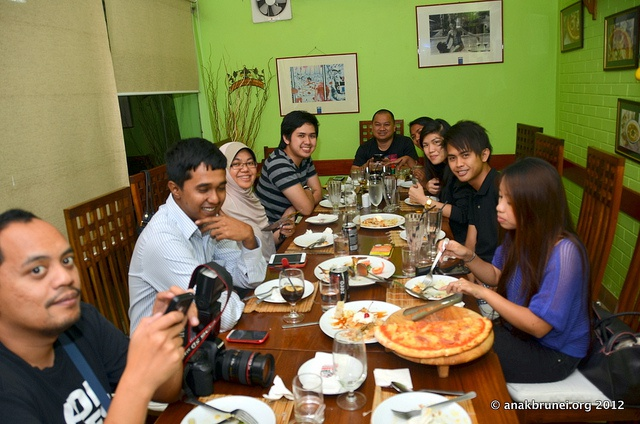Describe the objects in this image and their specific colors. I can see dining table in olive, ivory, maroon, black, and orange tones, people in olive, black, tan, and salmon tones, people in olive, black, navy, maroon, and blue tones, people in olive, lightgray, darkgray, and black tones, and chair in olive, maroon, black, and brown tones in this image. 